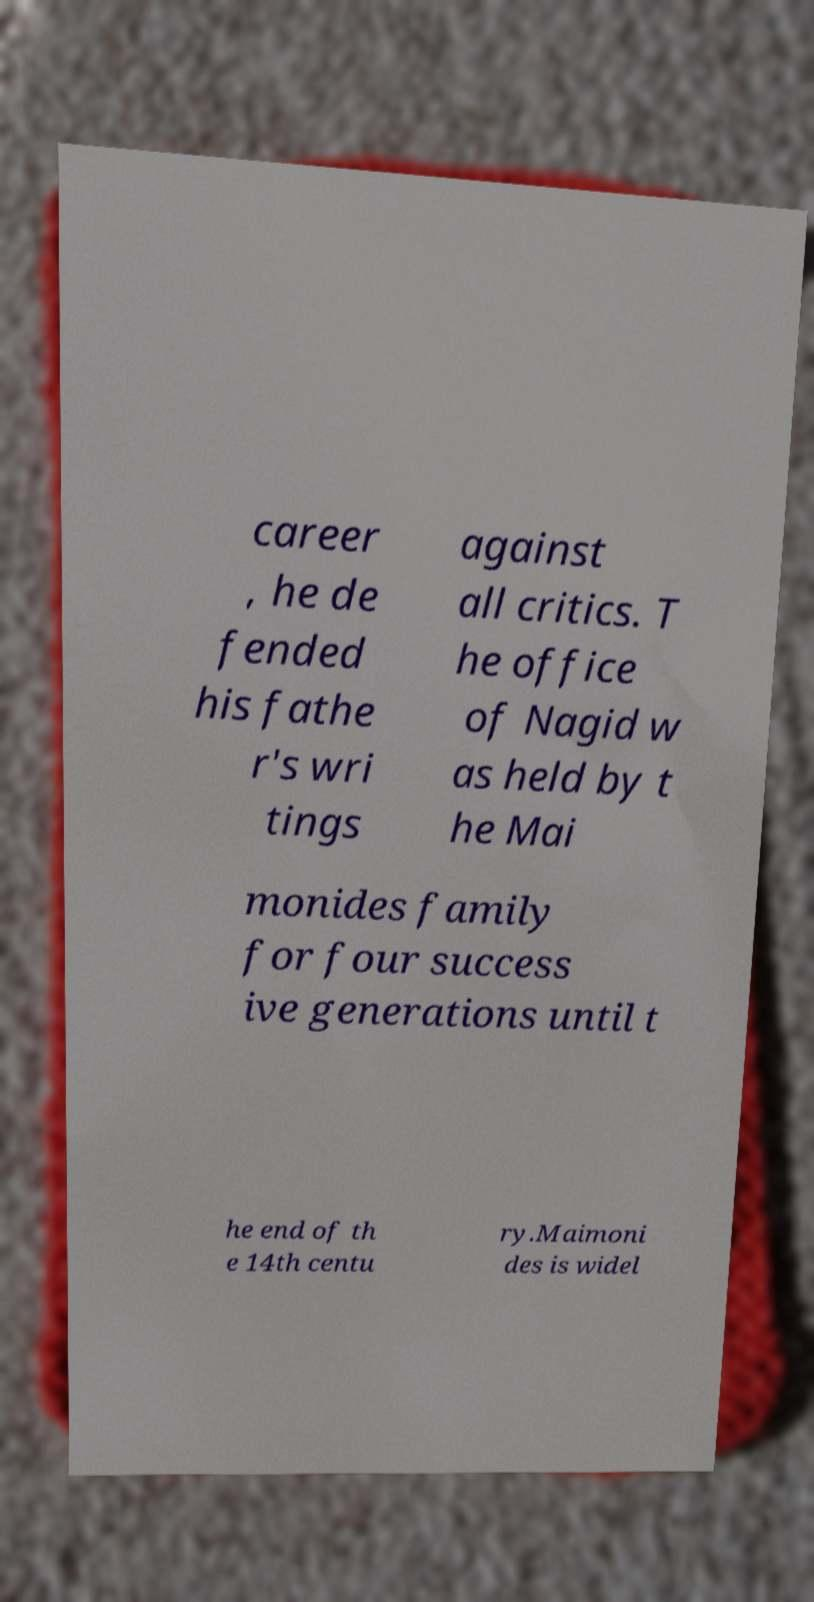Please identify and transcribe the text found in this image. career , he de fended his fathe r's wri tings against all critics. T he office of Nagid w as held by t he Mai monides family for four success ive generations until t he end of th e 14th centu ry.Maimoni des is widel 